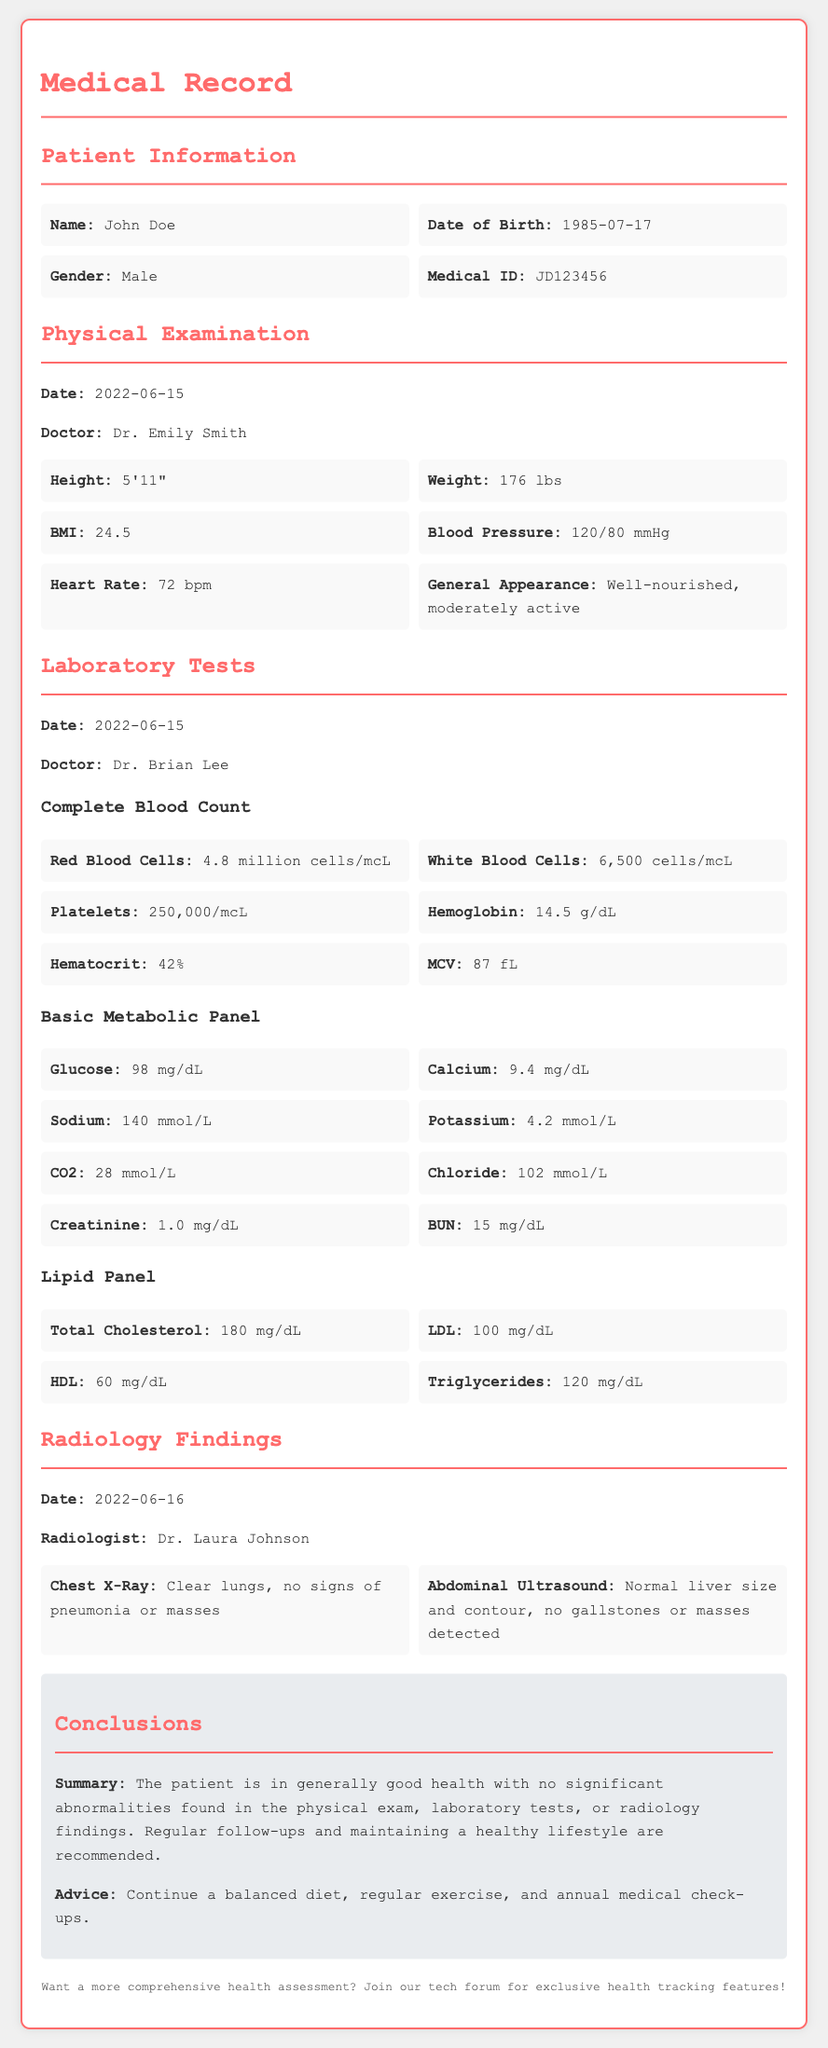what is the patient's name? The patient's name is clearly mentioned in the Patient Information section of the document.
Answer: John Doe what is the patient's date of birth? The date of birth is also listed in the Patient Information section.
Answer: 1985-07-17 who conducted the physical examination? The doctor's name who conducted the physical examination is stated in that section.
Answer: Dr. Emily Smith what was the patient's BMI? The BMI is found in the Physical Examination section.
Answer: 24.5 what are the results of the LDL test? The LDL results are specified in the Lipid Panel subsection of the Laboratory Tests section.
Answer: 100 mg/dL what was noted in the chest X-Ray report? The findings from the chest X-Ray are provided in the Radiology Findings section.
Answer: Clear lungs, no signs of pneumonia or masses what is the recommendation provided in the conclusion? The conclusions section includes summarized advice for the patient's health.
Answer: Continue a balanced diet, regular exercise, and annual medical check-ups how many years old is the patient in 2022? The age is determined by subtracting the birth year from 2022.
Answer: 37 years what is the patient's weight? The patient's weight can be found in the Physical Examination section.
Answer: 176 lbs 